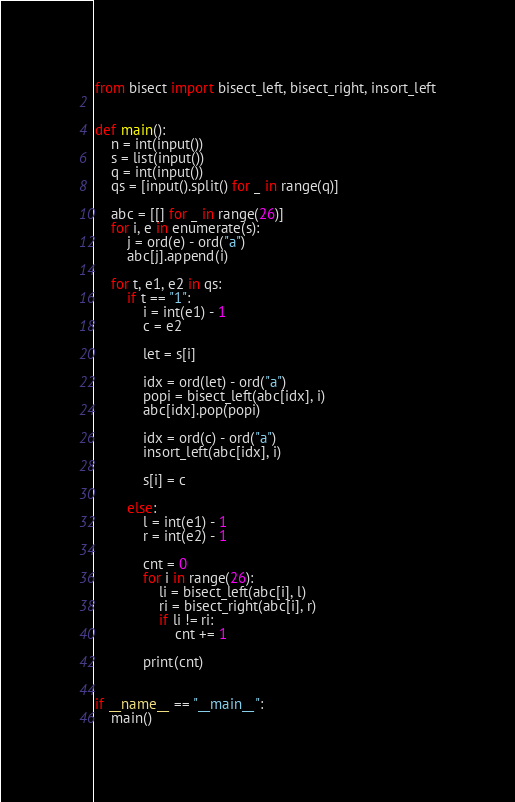<code> <loc_0><loc_0><loc_500><loc_500><_Python_>from bisect import bisect_left, bisect_right, insort_left


def main():
    n = int(input())
    s = list(input())
    q = int(input())
    qs = [input().split() for _ in range(q)]

    abc = [[] for _ in range(26)]
    for i, e in enumerate(s):
        j = ord(e) - ord("a")
        abc[j].append(i)

    for t, e1, e2 in qs:
        if t == "1":
            i = int(e1) - 1
            c = e2

            let = s[i]

            idx = ord(let) - ord("a")
            popi = bisect_left(abc[idx], i)
            abc[idx].pop(popi)

            idx = ord(c) - ord("a")
            insort_left(abc[idx], i)

            s[i] = c

        else:
            l = int(e1) - 1
            r = int(e2) - 1

            cnt = 0
            for i in range(26):
                li = bisect_left(abc[i], l)
                ri = bisect_right(abc[i], r)
                if li != ri:
                    cnt += 1

            print(cnt)


if __name__ == "__main__":
    main()
</code> 